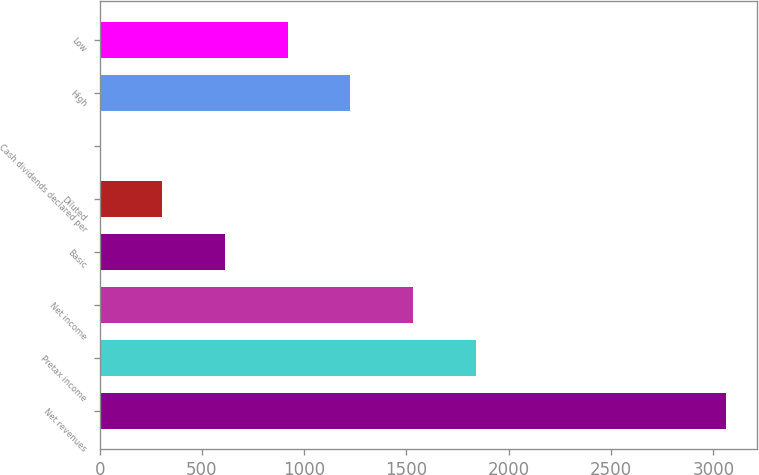Convert chart. <chart><loc_0><loc_0><loc_500><loc_500><bar_chart><fcel>Net revenues<fcel>Pretax income<fcel>Net income<fcel>Basic<fcel>Diluted<fcel>Cash dividends declared per<fcel>High<fcel>Low<nl><fcel>3062<fcel>1837.49<fcel>1531.37<fcel>613<fcel>306.88<fcel>0.75<fcel>1225.24<fcel>919.12<nl></chart> 